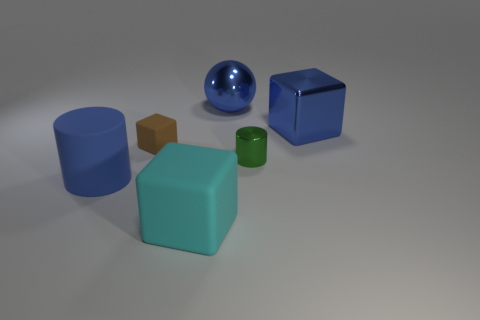Add 3 small purple matte objects. How many objects exist? 9 Subtract all cylinders. How many objects are left? 4 Add 5 large brown metallic objects. How many large brown metallic objects exist? 5 Subtract 1 green cylinders. How many objects are left? 5 Subtract all brown matte cubes. Subtract all cyan matte blocks. How many objects are left? 4 Add 4 shiny objects. How many shiny objects are left? 7 